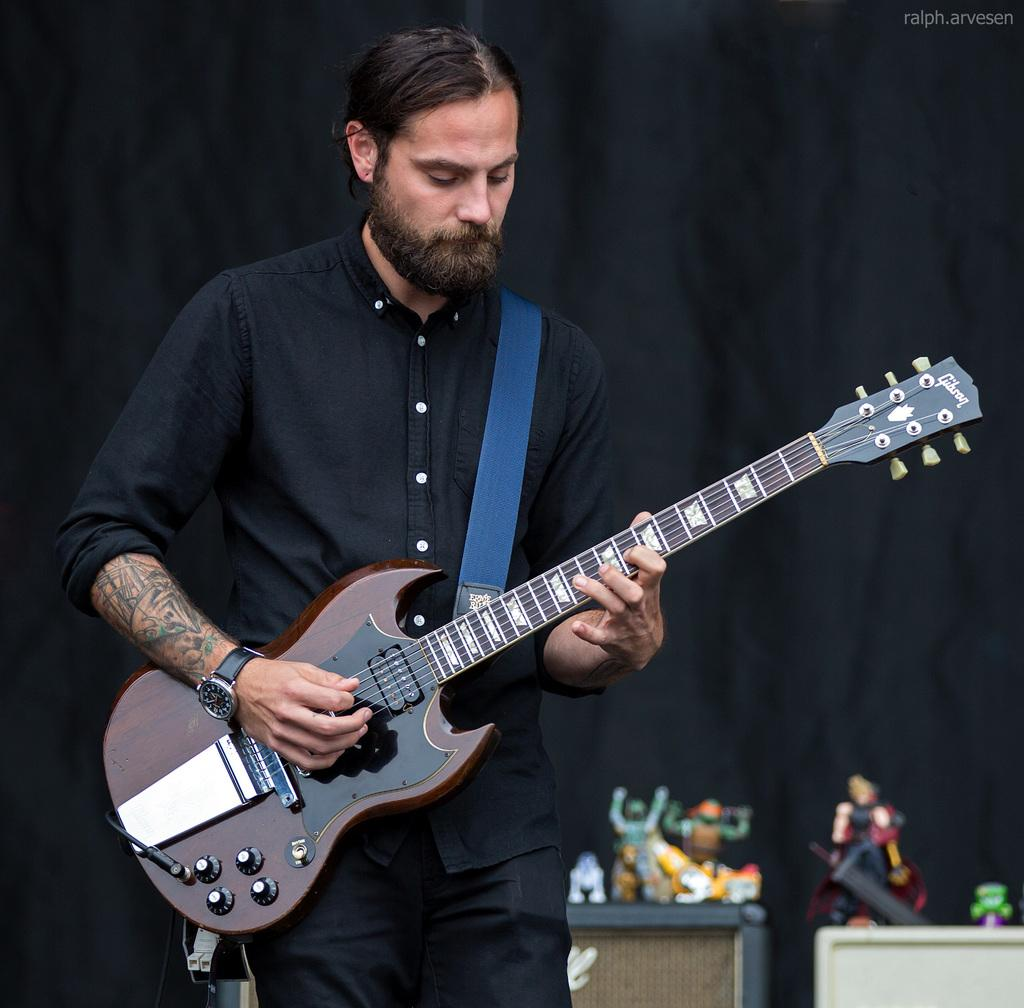What is the person in the image doing? The person in the image is standing and playing the guitar. What can be seen in the background of the image? There is a toy and a curtain visible in the background of the image. Where is the nest located in the image? There is no nest present in the image. What type of grain can be seen in the image? There is no grain present in the image. 